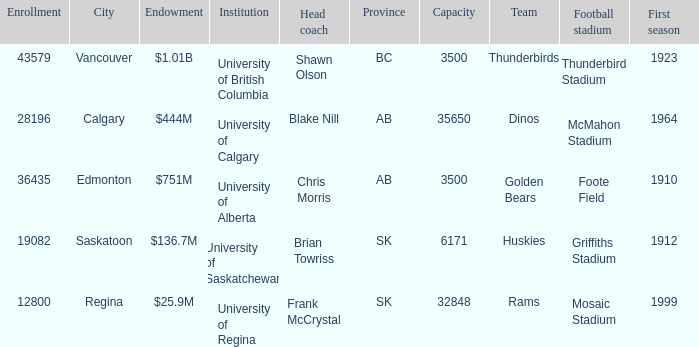What football stadium has a school enrollment of 43579? Thunderbird Stadium. 